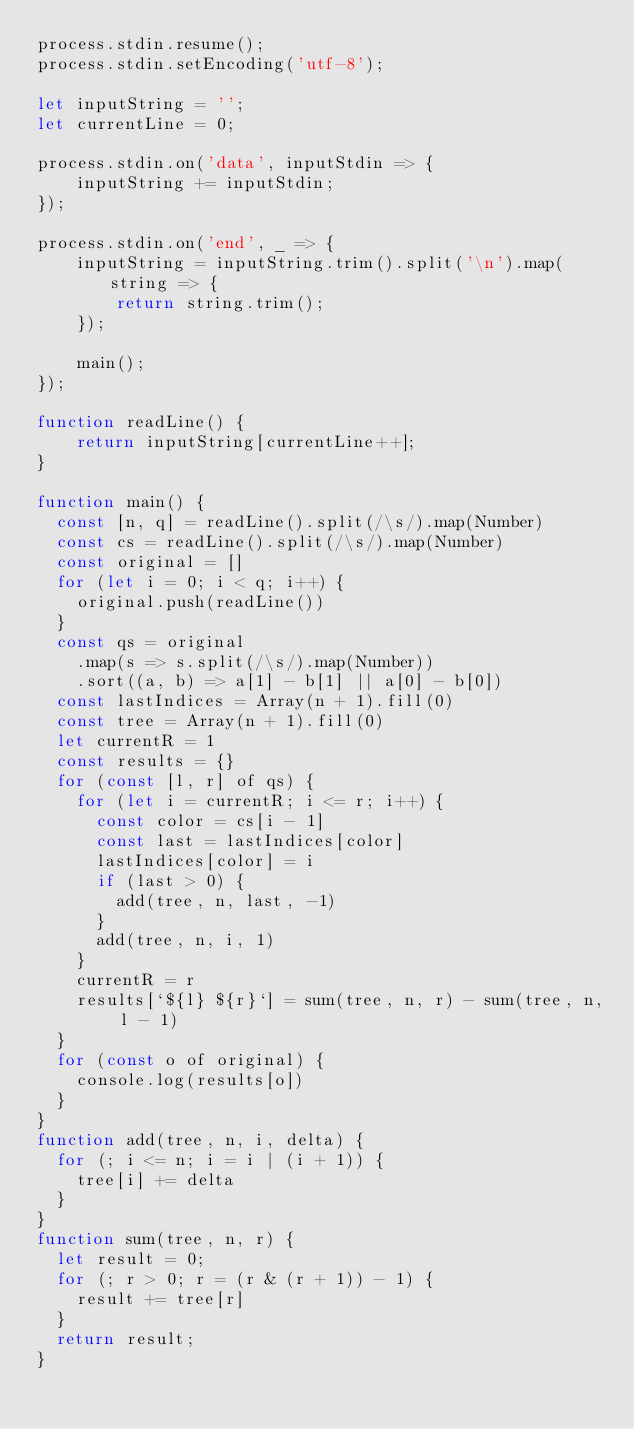Convert code to text. <code><loc_0><loc_0><loc_500><loc_500><_JavaScript_>process.stdin.resume();
process.stdin.setEncoding('utf-8');
 
let inputString = '';
let currentLine = 0;
 
process.stdin.on('data', inputStdin => {
    inputString += inputStdin;
});
 
process.stdin.on('end', _ => {
    inputString = inputString.trim().split('\n').map(string => {
        return string.trim();
    });
    
    main();    
});
 
function readLine() {
    return inputString[currentLine++];
}

function main() {
  const [n, q] = readLine().split(/\s/).map(Number)
  const cs = readLine().split(/\s/).map(Number)
  const original = []
  for (let i = 0; i < q; i++) {
    original.push(readLine())
  }
  const qs = original
    .map(s => s.split(/\s/).map(Number))
    .sort((a, b) => a[1] - b[1] || a[0] - b[0])
  const lastIndices = Array(n + 1).fill(0)
  const tree = Array(n + 1).fill(0)
  let currentR = 1
  const results = {}
  for (const [l, r] of qs) {
    for (let i = currentR; i <= r; i++) {
      const color = cs[i - 1]
      const last = lastIndices[color]
      lastIndices[color] = i
      if (last > 0) {
	    add(tree, n, last, -1)
      }
      add(tree, n, i, 1)
    }
    currentR = r
    results[`${l} ${r}`] = sum(tree, n, r) - sum(tree, n, l - 1)
  }
  for (const o of original) {
    console.log(results[o])
  }
}
function add(tree, n, i, delta) {
  for (; i <= n; i = i | (i + 1)) {
    tree[i] += delta
  }
}
function sum(tree, n, r) {
  let result = 0;
  for (; r > 0; r = (r & (r + 1)) - 1) {
    result += tree[r]
  }
  return result;
}</code> 